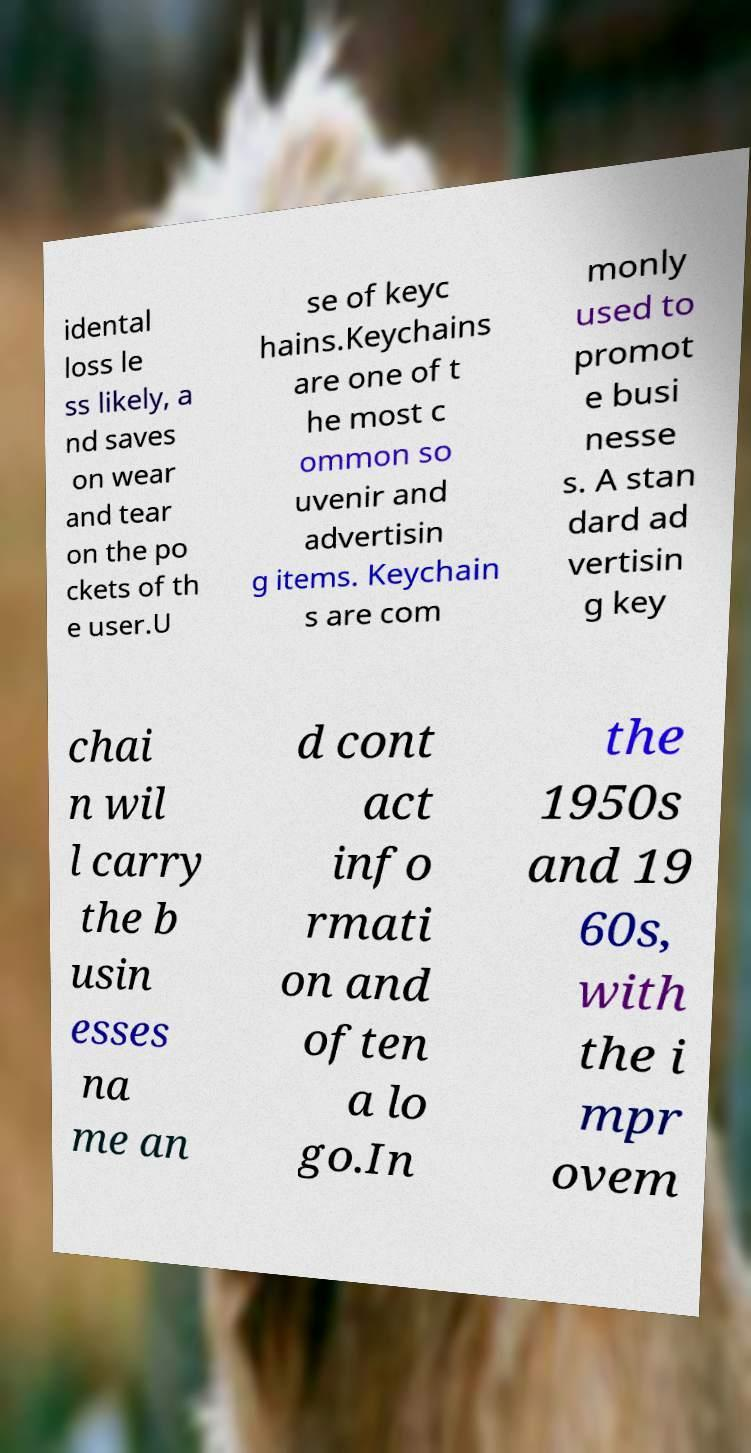Please read and relay the text visible in this image. What does it say? idental loss le ss likely, a nd saves on wear and tear on the po ckets of th e user.U se of keyc hains.Keychains are one of t he most c ommon so uvenir and advertisin g items. Keychain s are com monly used to promot e busi nesse s. A stan dard ad vertisin g key chai n wil l carry the b usin esses na me an d cont act info rmati on and often a lo go.In the 1950s and 19 60s, with the i mpr ovem 